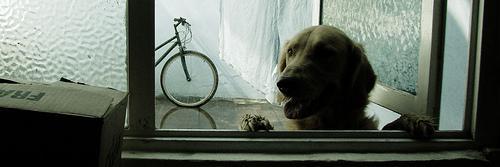How many of the people are on bicycles?
Give a very brief answer. 0. 